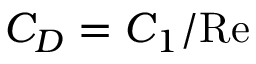<formula> <loc_0><loc_0><loc_500><loc_500>C _ { D } = C _ { 1 } / R e</formula> 